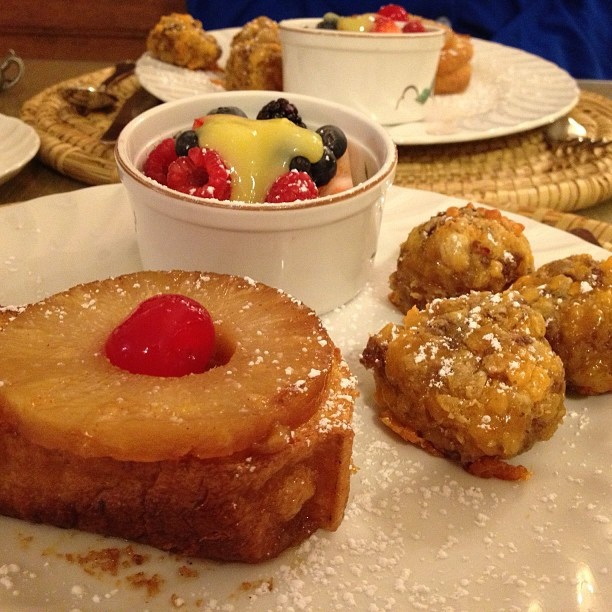Describe the objects in this image and their specific colors. I can see cake in maroon, red, brown, and orange tones, dining table in maroon, tan, and gray tones, bowl in maroon and tan tones, bowl in maroon and tan tones, and spoon in maroon and brown tones in this image. 